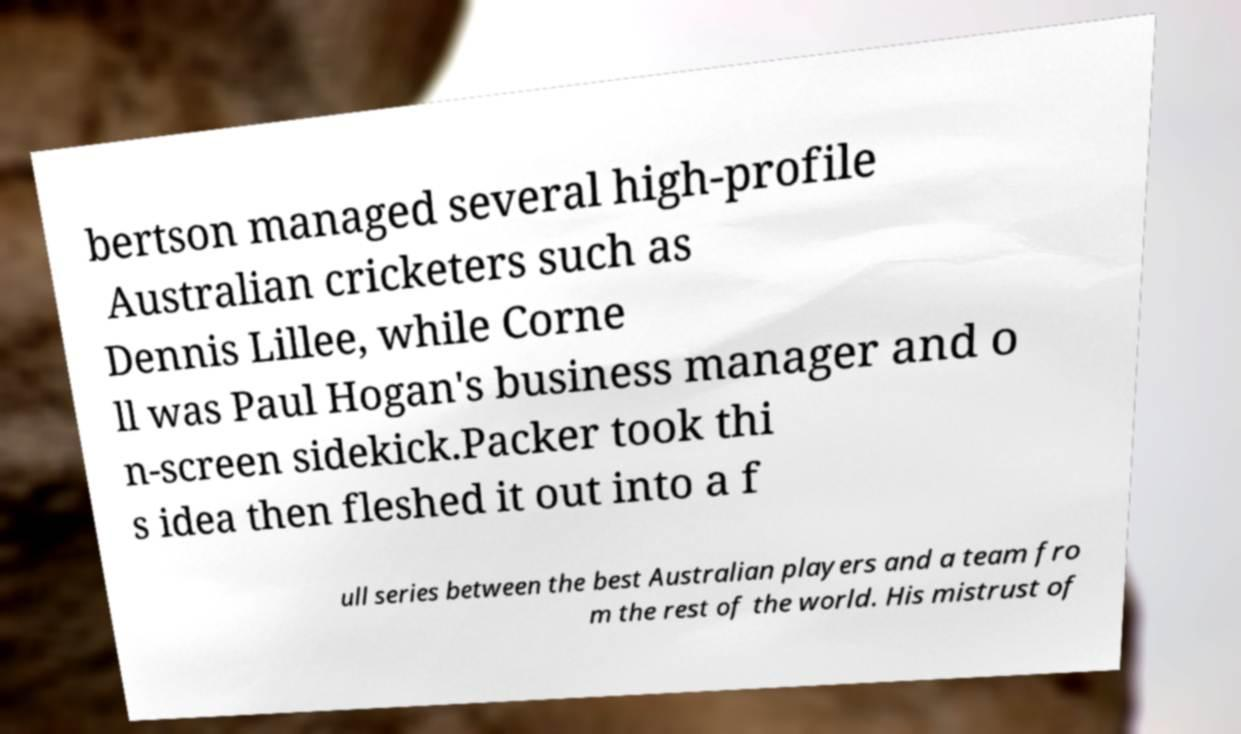I need the written content from this picture converted into text. Can you do that? bertson managed several high-profile Australian cricketers such as Dennis Lillee, while Corne ll was Paul Hogan's business manager and o n-screen sidekick.Packer took thi s idea then fleshed it out into a f ull series between the best Australian players and a team fro m the rest of the world. His mistrust of 